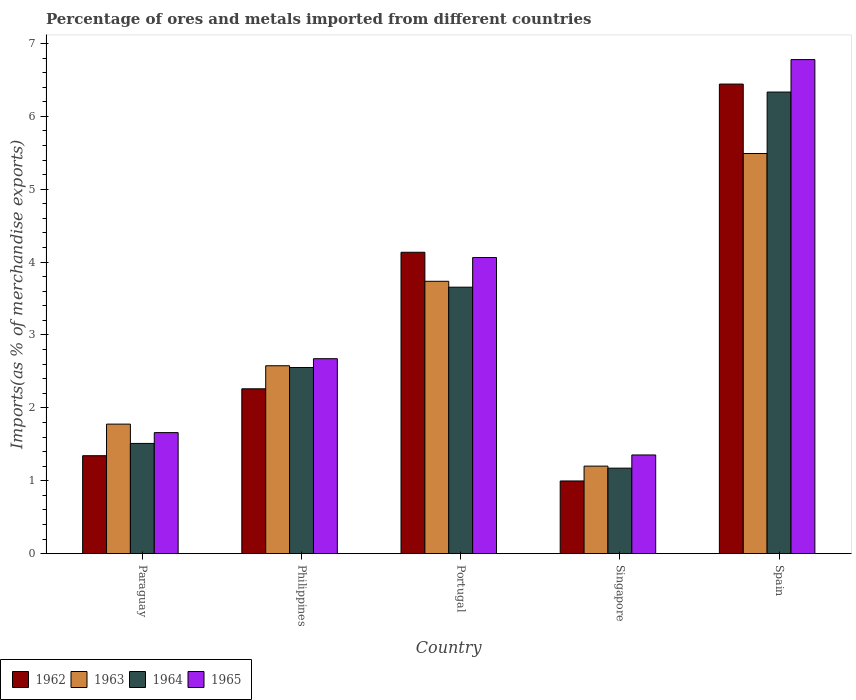Are the number of bars per tick equal to the number of legend labels?
Offer a terse response. Yes. Are the number of bars on each tick of the X-axis equal?
Offer a very short reply. Yes. How many bars are there on the 5th tick from the left?
Offer a terse response. 4. What is the percentage of imports to different countries in 1965 in Singapore?
Your answer should be compact. 1.35. Across all countries, what is the maximum percentage of imports to different countries in 1965?
Your answer should be very brief. 6.78. Across all countries, what is the minimum percentage of imports to different countries in 1963?
Keep it short and to the point. 1.2. In which country was the percentage of imports to different countries in 1963 maximum?
Offer a terse response. Spain. In which country was the percentage of imports to different countries in 1965 minimum?
Give a very brief answer. Singapore. What is the total percentage of imports to different countries in 1963 in the graph?
Your answer should be compact. 14.78. What is the difference between the percentage of imports to different countries in 1962 in Portugal and that in Singapore?
Your response must be concise. 3.14. What is the difference between the percentage of imports to different countries in 1962 in Singapore and the percentage of imports to different countries in 1964 in Philippines?
Offer a very short reply. -1.56. What is the average percentage of imports to different countries in 1962 per country?
Offer a terse response. 3.04. What is the difference between the percentage of imports to different countries of/in 1964 and percentage of imports to different countries of/in 1962 in Portugal?
Make the answer very short. -0.48. In how many countries, is the percentage of imports to different countries in 1962 greater than 6.8 %?
Keep it short and to the point. 0. What is the ratio of the percentage of imports to different countries in 1962 in Singapore to that in Spain?
Provide a succinct answer. 0.15. Is the percentage of imports to different countries in 1963 in Portugal less than that in Spain?
Your answer should be compact. Yes. What is the difference between the highest and the second highest percentage of imports to different countries in 1964?
Your answer should be very brief. -1.1. What is the difference between the highest and the lowest percentage of imports to different countries in 1963?
Your response must be concise. 4.29. Is it the case that in every country, the sum of the percentage of imports to different countries in 1962 and percentage of imports to different countries in 1965 is greater than the sum of percentage of imports to different countries in 1963 and percentage of imports to different countries in 1964?
Provide a succinct answer. No. What does the 4th bar from the left in Portugal represents?
Ensure brevity in your answer.  1965. What does the 2nd bar from the right in Paraguay represents?
Provide a short and direct response. 1964. How many bars are there?
Offer a very short reply. 20. How many countries are there in the graph?
Ensure brevity in your answer.  5. What is the difference between two consecutive major ticks on the Y-axis?
Provide a short and direct response. 1. Does the graph contain any zero values?
Your answer should be very brief. No. How are the legend labels stacked?
Offer a terse response. Horizontal. What is the title of the graph?
Give a very brief answer. Percentage of ores and metals imported from different countries. Does "1997" appear as one of the legend labels in the graph?
Offer a very short reply. No. What is the label or title of the X-axis?
Offer a very short reply. Country. What is the label or title of the Y-axis?
Your answer should be compact. Imports(as % of merchandise exports). What is the Imports(as % of merchandise exports) of 1962 in Paraguay?
Ensure brevity in your answer.  1.34. What is the Imports(as % of merchandise exports) in 1963 in Paraguay?
Your answer should be very brief. 1.78. What is the Imports(as % of merchandise exports) in 1964 in Paraguay?
Ensure brevity in your answer.  1.51. What is the Imports(as % of merchandise exports) of 1965 in Paraguay?
Provide a short and direct response. 1.66. What is the Imports(as % of merchandise exports) in 1962 in Philippines?
Make the answer very short. 2.26. What is the Imports(as % of merchandise exports) in 1963 in Philippines?
Provide a succinct answer. 2.58. What is the Imports(as % of merchandise exports) of 1964 in Philippines?
Make the answer very short. 2.55. What is the Imports(as % of merchandise exports) in 1965 in Philippines?
Provide a succinct answer. 2.67. What is the Imports(as % of merchandise exports) of 1962 in Portugal?
Give a very brief answer. 4.13. What is the Imports(as % of merchandise exports) of 1963 in Portugal?
Your answer should be very brief. 3.74. What is the Imports(as % of merchandise exports) of 1964 in Portugal?
Ensure brevity in your answer.  3.66. What is the Imports(as % of merchandise exports) of 1965 in Portugal?
Your answer should be compact. 4.06. What is the Imports(as % of merchandise exports) of 1962 in Singapore?
Offer a very short reply. 1. What is the Imports(as % of merchandise exports) in 1963 in Singapore?
Give a very brief answer. 1.2. What is the Imports(as % of merchandise exports) of 1964 in Singapore?
Your answer should be compact. 1.17. What is the Imports(as % of merchandise exports) of 1965 in Singapore?
Make the answer very short. 1.35. What is the Imports(as % of merchandise exports) in 1962 in Spain?
Make the answer very short. 6.44. What is the Imports(as % of merchandise exports) of 1963 in Spain?
Your response must be concise. 5.49. What is the Imports(as % of merchandise exports) of 1964 in Spain?
Make the answer very short. 6.33. What is the Imports(as % of merchandise exports) of 1965 in Spain?
Ensure brevity in your answer.  6.78. Across all countries, what is the maximum Imports(as % of merchandise exports) in 1962?
Your response must be concise. 6.44. Across all countries, what is the maximum Imports(as % of merchandise exports) in 1963?
Keep it short and to the point. 5.49. Across all countries, what is the maximum Imports(as % of merchandise exports) of 1964?
Make the answer very short. 6.33. Across all countries, what is the maximum Imports(as % of merchandise exports) in 1965?
Offer a very short reply. 6.78. Across all countries, what is the minimum Imports(as % of merchandise exports) of 1962?
Ensure brevity in your answer.  1. Across all countries, what is the minimum Imports(as % of merchandise exports) in 1963?
Your answer should be compact. 1.2. Across all countries, what is the minimum Imports(as % of merchandise exports) of 1964?
Provide a succinct answer. 1.17. Across all countries, what is the minimum Imports(as % of merchandise exports) of 1965?
Make the answer very short. 1.35. What is the total Imports(as % of merchandise exports) in 1962 in the graph?
Offer a terse response. 15.18. What is the total Imports(as % of merchandise exports) of 1963 in the graph?
Offer a terse response. 14.78. What is the total Imports(as % of merchandise exports) in 1964 in the graph?
Provide a succinct answer. 15.23. What is the total Imports(as % of merchandise exports) of 1965 in the graph?
Ensure brevity in your answer.  16.53. What is the difference between the Imports(as % of merchandise exports) in 1962 in Paraguay and that in Philippines?
Provide a short and direct response. -0.92. What is the difference between the Imports(as % of merchandise exports) of 1963 in Paraguay and that in Philippines?
Your answer should be compact. -0.8. What is the difference between the Imports(as % of merchandise exports) in 1964 in Paraguay and that in Philippines?
Your response must be concise. -1.04. What is the difference between the Imports(as % of merchandise exports) in 1965 in Paraguay and that in Philippines?
Offer a terse response. -1.01. What is the difference between the Imports(as % of merchandise exports) of 1962 in Paraguay and that in Portugal?
Offer a terse response. -2.79. What is the difference between the Imports(as % of merchandise exports) in 1963 in Paraguay and that in Portugal?
Keep it short and to the point. -1.96. What is the difference between the Imports(as % of merchandise exports) of 1964 in Paraguay and that in Portugal?
Offer a very short reply. -2.14. What is the difference between the Imports(as % of merchandise exports) of 1965 in Paraguay and that in Portugal?
Your answer should be compact. -2.4. What is the difference between the Imports(as % of merchandise exports) of 1962 in Paraguay and that in Singapore?
Offer a very short reply. 0.35. What is the difference between the Imports(as % of merchandise exports) of 1963 in Paraguay and that in Singapore?
Provide a succinct answer. 0.58. What is the difference between the Imports(as % of merchandise exports) in 1964 in Paraguay and that in Singapore?
Keep it short and to the point. 0.34. What is the difference between the Imports(as % of merchandise exports) of 1965 in Paraguay and that in Singapore?
Give a very brief answer. 0.31. What is the difference between the Imports(as % of merchandise exports) of 1962 in Paraguay and that in Spain?
Keep it short and to the point. -5.1. What is the difference between the Imports(as % of merchandise exports) of 1963 in Paraguay and that in Spain?
Provide a succinct answer. -3.71. What is the difference between the Imports(as % of merchandise exports) in 1964 in Paraguay and that in Spain?
Provide a succinct answer. -4.82. What is the difference between the Imports(as % of merchandise exports) in 1965 in Paraguay and that in Spain?
Ensure brevity in your answer.  -5.12. What is the difference between the Imports(as % of merchandise exports) in 1962 in Philippines and that in Portugal?
Provide a short and direct response. -1.87. What is the difference between the Imports(as % of merchandise exports) in 1963 in Philippines and that in Portugal?
Make the answer very short. -1.16. What is the difference between the Imports(as % of merchandise exports) in 1964 in Philippines and that in Portugal?
Offer a very short reply. -1.1. What is the difference between the Imports(as % of merchandise exports) in 1965 in Philippines and that in Portugal?
Offer a terse response. -1.39. What is the difference between the Imports(as % of merchandise exports) in 1962 in Philippines and that in Singapore?
Provide a short and direct response. 1.26. What is the difference between the Imports(as % of merchandise exports) in 1963 in Philippines and that in Singapore?
Provide a short and direct response. 1.38. What is the difference between the Imports(as % of merchandise exports) of 1964 in Philippines and that in Singapore?
Your answer should be very brief. 1.38. What is the difference between the Imports(as % of merchandise exports) of 1965 in Philippines and that in Singapore?
Offer a very short reply. 1.32. What is the difference between the Imports(as % of merchandise exports) of 1962 in Philippines and that in Spain?
Your answer should be compact. -4.18. What is the difference between the Imports(as % of merchandise exports) in 1963 in Philippines and that in Spain?
Ensure brevity in your answer.  -2.91. What is the difference between the Imports(as % of merchandise exports) in 1964 in Philippines and that in Spain?
Offer a terse response. -3.78. What is the difference between the Imports(as % of merchandise exports) in 1965 in Philippines and that in Spain?
Your answer should be very brief. -4.1. What is the difference between the Imports(as % of merchandise exports) in 1962 in Portugal and that in Singapore?
Provide a short and direct response. 3.14. What is the difference between the Imports(as % of merchandise exports) in 1963 in Portugal and that in Singapore?
Give a very brief answer. 2.54. What is the difference between the Imports(as % of merchandise exports) in 1964 in Portugal and that in Singapore?
Keep it short and to the point. 2.48. What is the difference between the Imports(as % of merchandise exports) in 1965 in Portugal and that in Singapore?
Offer a very short reply. 2.71. What is the difference between the Imports(as % of merchandise exports) of 1962 in Portugal and that in Spain?
Your answer should be compact. -2.31. What is the difference between the Imports(as % of merchandise exports) of 1963 in Portugal and that in Spain?
Offer a very short reply. -1.75. What is the difference between the Imports(as % of merchandise exports) of 1964 in Portugal and that in Spain?
Provide a succinct answer. -2.68. What is the difference between the Imports(as % of merchandise exports) of 1965 in Portugal and that in Spain?
Ensure brevity in your answer.  -2.72. What is the difference between the Imports(as % of merchandise exports) in 1962 in Singapore and that in Spain?
Your response must be concise. -5.45. What is the difference between the Imports(as % of merchandise exports) of 1963 in Singapore and that in Spain?
Give a very brief answer. -4.29. What is the difference between the Imports(as % of merchandise exports) of 1964 in Singapore and that in Spain?
Keep it short and to the point. -5.16. What is the difference between the Imports(as % of merchandise exports) in 1965 in Singapore and that in Spain?
Your answer should be compact. -5.42. What is the difference between the Imports(as % of merchandise exports) of 1962 in Paraguay and the Imports(as % of merchandise exports) of 1963 in Philippines?
Ensure brevity in your answer.  -1.23. What is the difference between the Imports(as % of merchandise exports) of 1962 in Paraguay and the Imports(as % of merchandise exports) of 1964 in Philippines?
Ensure brevity in your answer.  -1.21. What is the difference between the Imports(as % of merchandise exports) in 1962 in Paraguay and the Imports(as % of merchandise exports) in 1965 in Philippines?
Provide a succinct answer. -1.33. What is the difference between the Imports(as % of merchandise exports) of 1963 in Paraguay and the Imports(as % of merchandise exports) of 1964 in Philippines?
Offer a terse response. -0.78. What is the difference between the Imports(as % of merchandise exports) in 1963 in Paraguay and the Imports(as % of merchandise exports) in 1965 in Philippines?
Provide a succinct answer. -0.9. What is the difference between the Imports(as % of merchandise exports) in 1964 in Paraguay and the Imports(as % of merchandise exports) in 1965 in Philippines?
Your answer should be very brief. -1.16. What is the difference between the Imports(as % of merchandise exports) in 1962 in Paraguay and the Imports(as % of merchandise exports) in 1963 in Portugal?
Your answer should be very brief. -2.39. What is the difference between the Imports(as % of merchandise exports) in 1962 in Paraguay and the Imports(as % of merchandise exports) in 1964 in Portugal?
Give a very brief answer. -2.31. What is the difference between the Imports(as % of merchandise exports) in 1962 in Paraguay and the Imports(as % of merchandise exports) in 1965 in Portugal?
Your response must be concise. -2.72. What is the difference between the Imports(as % of merchandise exports) in 1963 in Paraguay and the Imports(as % of merchandise exports) in 1964 in Portugal?
Provide a short and direct response. -1.88. What is the difference between the Imports(as % of merchandise exports) of 1963 in Paraguay and the Imports(as % of merchandise exports) of 1965 in Portugal?
Keep it short and to the point. -2.29. What is the difference between the Imports(as % of merchandise exports) in 1964 in Paraguay and the Imports(as % of merchandise exports) in 1965 in Portugal?
Provide a succinct answer. -2.55. What is the difference between the Imports(as % of merchandise exports) in 1962 in Paraguay and the Imports(as % of merchandise exports) in 1963 in Singapore?
Your answer should be compact. 0.14. What is the difference between the Imports(as % of merchandise exports) of 1962 in Paraguay and the Imports(as % of merchandise exports) of 1964 in Singapore?
Offer a terse response. 0.17. What is the difference between the Imports(as % of merchandise exports) of 1962 in Paraguay and the Imports(as % of merchandise exports) of 1965 in Singapore?
Your response must be concise. -0.01. What is the difference between the Imports(as % of merchandise exports) of 1963 in Paraguay and the Imports(as % of merchandise exports) of 1964 in Singapore?
Provide a succinct answer. 0.6. What is the difference between the Imports(as % of merchandise exports) in 1963 in Paraguay and the Imports(as % of merchandise exports) in 1965 in Singapore?
Provide a succinct answer. 0.42. What is the difference between the Imports(as % of merchandise exports) in 1964 in Paraguay and the Imports(as % of merchandise exports) in 1965 in Singapore?
Your response must be concise. 0.16. What is the difference between the Imports(as % of merchandise exports) in 1962 in Paraguay and the Imports(as % of merchandise exports) in 1963 in Spain?
Keep it short and to the point. -4.15. What is the difference between the Imports(as % of merchandise exports) in 1962 in Paraguay and the Imports(as % of merchandise exports) in 1964 in Spain?
Offer a terse response. -4.99. What is the difference between the Imports(as % of merchandise exports) in 1962 in Paraguay and the Imports(as % of merchandise exports) in 1965 in Spain?
Offer a very short reply. -5.43. What is the difference between the Imports(as % of merchandise exports) of 1963 in Paraguay and the Imports(as % of merchandise exports) of 1964 in Spain?
Your answer should be very brief. -4.56. What is the difference between the Imports(as % of merchandise exports) of 1963 in Paraguay and the Imports(as % of merchandise exports) of 1965 in Spain?
Offer a terse response. -5. What is the difference between the Imports(as % of merchandise exports) in 1964 in Paraguay and the Imports(as % of merchandise exports) in 1965 in Spain?
Your answer should be compact. -5.27. What is the difference between the Imports(as % of merchandise exports) in 1962 in Philippines and the Imports(as % of merchandise exports) in 1963 in Portugal?
Ensure brevity in your answer.  -1.47. What is the difference between the Imports(as % of merchandise exports) of 1962 in Philippines and the Imports(as % of merchandise exports) of 1964 in Portugal?
Offer a terse response. -1.39. What is the difference between the Imports(as % of merchandise exports) in 1962 in Philippines and the Imports(as % of merchandise exports) in 1965 in Portugal?
Your answer should be very brief. -1.8. What is the difference between the Imports(as % of merchandise exports) in 1963 in Philippines and the Imports(as % of merchandise exports) in 1964 in Portugal?
Keep it short and to the point. -1.08. What is the difference between the Imports(as % of merchandise exports) of 1963 in Philippines and the Imports(as % of merchandise exports) of 1965 in Portugal?
Keep it short and to the point. -1.48. What is the difference between the Imports(as % of merchandise exports) of 1964 in Philippines and the Imports(as % of merchandise exports) of 1965 in Portugal?
Your answer should be compact. -1.51. What is the difference between the Imports(as % of merchandise exports) in 1962 in Philippines and the Imports(as % of merchandise exports) in 1963 in Singapore?
Make the answer very short. 1.06. What is the difference between the Imports(as % of merchandise exports) in 1962 in Philippines and the Imports(as % of merchandise exports) in 1964 in Singapore?
Your response must be concise. 1.09. What is the difference between the Imports(as % of merchandise exports) of 1962 in Philippines and the Imports(as % of merchandise exports) of 1965 in Singapore?
Provide a succinct answer. 0.91. What is the difference between the Imports(as % of merchandise exports) of 1963 in Philippines and the Imports(as % of merchandise exports) of 1964 in Singapore?
Offer a very short reply. 1.4. What is the difference between the Imports(as % of merchandise exports) in 1963 in Philippines and the Imports(as % of merchandise exports) in 1965 in Singapore?
Offer a terse response. 1.22. What is the difference between the Imports(as % of merchandise exports) in 1964 in Philippines and the Imports(as % of merchandise exports) in 1965 in Singapore?
Make the answer very short. 1.2. What is the difference between the Imports(as % of merchandise exports) in 1962 in Philippines and the Imports(as % of merchandise exports) in 1963 in Spain?
Provide a short and direct response. -3.23. What is the difference between the Imports(as % of merchandise exports) of 1962 in Philippines and the Imports(as % of merchandise exports) of 1964 in Spain?
Provide a short and direct response. -4.07. What is the difference between the Imports(as % of merchandise exports) of 1962 in Philippines and the Imports(as % of merchandise exports) of 1965 in Spain?
Offer a very short reply. -4.52. What is the difference between the Imports(as % of merchandise exports) in 1963 in Philippines and the Imports(as % of merchandise exports) in 1964 in Spain?
Your answer should be compact. -3.75. What is the difference between the Imports(as % of merchandise exports) of 1963 in Philippines and the Imports(as % of merchandise exports) of 1965 in Spain?
Give a very brief answer. -4.2. What is the difference between the Imports(as % of merchandise exports) in 1964 in Philippines and the Imports(as % of merchandise exports) in 1965 in Spain?
Offer a very short reply. -4.22. What is the difference between the Imports(as % of merchandise exports) in 1962 in Portugal and the Imports(as % of merchandise exports) in 1963 in Singapore?
Ensure brevity in your answer.  2.93. What is the difference between the Imports(as % of merchandise exports) of 1962 in Portugal and the Imports(as % of merchandise exports) of 1964 in Singapore?
Your answer should be very brief. 2.96. What is the difference between the Imports(as % of merchandise exports) of 1962 in Portugal and the Imports(as % of merchandise exports) of 1965 in Singapore?
Keep it short and to the point. 2.78. What is the difference between the Imports(as % of merchandise exports) of 1963 in Portugal and the Imports(as % of merchandise exports) of 1964 in Singapore?
Provide a short and direct response. 2.56. What is the difference between the Imports(as % of merchandise exports) of 1963 in Portugal and the Imports(as % of merchandise exports) of 1965 in Singapore?
Your answer should be compact. 2.38. What is the difference between the Imports(as % of merchandise exports) of 1964 in Portugal and the Imports(as % of merchandise exports) of 1965 in Singapore?
Your response must be concise. 2.3. What is the difference between the Imports(as % of merchandise exports) of 1962 in Portugal and the Imports(as % of merchandise exports) of 1963 in Spain?
Make the answer very short. -1.36. What is the difference between the Imports(as % of merchandise exports) in 1962 in Portugal and the Imports(as % of merchandise exports) in 1964 in Spain?
Give a very brief answer. -2.2. What is the difference between the Imports(as % of merchandise exports) in 1962 in Portugal and the Imports(as % of merchandise exports) in 1965 in Spain?
Your answer should be very brief. -2.64. What is the difference between the Imports(as % of merchandise exports) of 1963 in Portugal and the Imports(as % of merchandise exports) of 1964 in Spain?
Your answer should be very brief. -2.6. What is the difference between the Imports(as % of merchandise exports) of 1963 in Portugal and the Imports(as % of merchandise exports) of 1965 in Spain?
Your answer should be compact. -3.04. What is the difference between the Imports(as % of merchandise exports) of 1964 in Portugal and the Imports(as % of merchandise exports) of 1965 in Spain?
Provide a short and direct response. -3.12. What is the difference between the Imports(as % of merchandise exports) of 1962 in Singapore and the Imports(as % of merchandise exports) of 1963 in Spain?
Your answer should be very brief. -4.49. What is the difference between the Imports(as % of merchandise exports) of 1962 in Singapore and the Imports(as % of merchandise exports) of 1964 in Spain?
Offer a very short reply. -5.34. What is the difference between the Imports(as % of merchandise exports) in 1962 in Singapore and the Imports(as % of merchandise exports) in 1965 in Spain?
Give a very brief answer. -5.78. What is the difference between the Imports(as % of merchandise exports) of 1963 in Singapore and the Imports(as % of merchandise exports) of 1964 in Spain?
Provide a short and direct response. -5.13. What is the difference between the Imports(as % of merchandise exports) in 1963 in Singapore and the Imports(as % of merchandise exports) in 1965 in Spain?
Offer a very short reply. -5.58. What is the difference between the Imports(as % of merchandise exports) in 1964 in Singapore and the Imports(as % of merchandise exports) in 1965 in Spain?
Your answer should be compact. -5.61. What is the average Imports(as % of merchandise exports) of 1962 per country?
Provide a succinct answer. 3.04. What is the average Imports(as % of merchandise exports) of 1963 per country?
Your answer should be very brief. 2.96. What is the average Imports(as % of merchandise exports) in 1964 per country?
Your answer should be very brief. 3.05. What is the average Imports(as % of merchandise exports) in 1965 per country?
Your answer should be very brief. 3.31. What is the difference between the Imports(as % of merchandise exports) of 1962 and Imports(as % of merchandise exports) of 1963 in Paraguay?
Provide a short and direct response. -0.43. What is the difference between the Imports(as % of merchandise exports) in 1962 and Imports(as % of merchandise exports) in 1964 in Paraguay?
Ensure brevity in your answer.  -0.17. What is the difference between the Imports(as % of merchandise exports) in 1962 and Imports(as % of merchandise exports) in 1965 in Paraguay?
Your answer should be very brief. -0.32. What is the difference between the Imports(as % of merchandise exports) of 1963 and Imports(as % of merchandise exports) of 1964 in Paraguay?
Make the answer very short. 0.26. What is the difference between the Imports(as % of merchandise exports) of 1963 and Imports(as % of merchandise exports) of 1965 in Paraguay?
Keep it short and to the point. 0.12. What is the difference between the Imports(as % of merchandise exports) of 1964 and Imports(as % of merchandise exports) of 1965 in Paraguay?
Provide a short and direct response. -0.15. What is the difference between the Imports(as % of merchandise exports) of 1962 and Imports(as % of merchandise exports) of 1963 in Philippines?
Ensure brevity in your answer.  -0.32. What is the difference between the Imports(as % of merchandise exports) of 1962 and Imports(as % of merchandise exports) of 1964 in Philippines?
Offer a terse response. -0.29. What is the difference between the Imports(as % of merchandise exports) of 1962 and Imports(as % of merchandise exports) of 1965 in Philippines?
Your response must be concise. -0.41. What is the difference between the Imports(as % of merchandise exports) of 1963 and Imports(as % of merchandise exports) of 1964 in Philippines?
Offer a terse response. 0.02. What is the difference between the Imports(as % of merchandise exports) of 1963 and Imports(as % of merchandise exports) of 1965 in Philippines?
Your answer should be compact. -0.1. What is the difference between the Imports(as % of merchandise exports) of 1964 and Imports(as % of merchandise exports) of 1965 in Philippines?
Keep it short and to the point. -0.12. What is the difference between the Imports(as % of merchandise exports) of 1962 and Imports(as % of merchandise exports) of 1963 in Portugal?
Offer a very short reply. 0.4. What is the difference between the Imports(as % of merchandise exports) in 1962 and Imports(as % of merchandise exports) in 1964 in Portugal?
Provide a short and direct response. 0.48. What is the difference between the Imports(as % of merchandise exports) in 1962 and Imports(as % of merchandise exports) in 1965 in Portugal?
Your response must be concise. 0.07. What is the difference between the Imports(as % of merchandise exports) in 1963 and Imports(as % of merchandise exports) in 1964 in Portugal?
Your answer should be very brief. 0.08. What is the difference between the Imports(as % of merchandise exports) of 1963 and Imports(as % of merchandise exports) of 1965 in Portugal?
Provide a succinct answer. -0.33. What is the difference between the Imports(as % of merchandise exports) in 1964 and Imports(as % of merchandise exports) in 1965 in Portugal?
Make the answer very short. -0.41. What is the difference between the Imports(as % of merchandise exports) of 1962 and Imports(as % of merchandise exports) of 1963 in Singapore?
Provide a succinct answer. -0.2. What is the difference between the Imports(as % of merchandise exports) of 1962 and Imports(as % of merchandise exports) of 1964 in Singapore?
Offer a very short reply. -0.18. What is the difference between the Imports(as % of merchandise exports) in 1962 and Imports(as % of merchandise exports) in 1965 in Singapore?
Make the answer very short. -0.36. What is the difference between the Imports(as % of merchandise exports) in 1963 and Imports(as % of merchandise exports) in 1964 in Singapore?
Your answer should be compact. 0.03. What is the difference between the Imports(as % of merchandise exports) in 1963 and Imports(as % of merchandise exports) in 1965 in Singapore?
Your response must be concise. -0.15. What is the difference between the Imports(as % of merchandise exports) of 1964 and Imports(as % of merchandise exports) of 1965 in Singapore?
Offer a terse response. -0.18. What is the difference between the Imports(as % of merchandise exports) of 1962 and Imports(as % of merchandise exports) of 1964 in Spain?
Ensure brevity in your answer.  0.11. What is the difference between the Imports(as % of merchandise exports) in 1962 and Imports(as % of merchandise exports) in 1965 in Spain?
Provide a short and direct response. -0.34. What is the difference between the Imports(as % of merchandise exports) of 1963 and Imports(as % of merchandise exports) of 1964 in Spain?
Ensure brevity in your answer.  -0.84. What is the difference between the Imports(as % of merchandise exports) of 1963 and Imports(as % of merchandise exports) of 1965 in Spain?
Offer a very short reply. -1.29. What is the difference between the Imports(as % of merchandise exports) of 1964 and Imports(as % of merchandise exports) of 1965 in Spain?
Make the answer very short. -0.45. What is the ratio of the Imports(as % of merchandise exports) of 1962 in Paraguay to that in Philippines?
Your answer should be very brief. 0.59. What is the ratio of the Imports(as % of merchandise exports) in 1963 in Paraguay to that in Philippines?
Offer a terse response. 0.69. What is the ratio of the Imports(as % of merchandise exports) in 1964 in Paraguay to that in Philippines?
Your answer should be very brief. 0.59. What is the ratio of the Imports(as % of merchandise exports) in 1965 in Paraguay to that in Philippines?
Keep it short and to the point. 0.62. What is the ratio of the Imports(as % of merchandise exports) of 1962 in Paraguay to that in Portugal?
Your answer should be compact. 0.33. What is the ratio of the Imports(as % of merchandise exports) in 1963 in Paraguay to that in Portugal?
Offer a terse response. 0.48. What is the ratio of the Imports(as % of merchandise exports) of 1964 in Paraguay to that in Portugal?
Provide a short and direct response. 0.41. What is the ratio of the Imports(as % of merchandise exports) in 1965 in Paraguay to that in Portugal?
Provide a succinct answer. 0.41. What is the ratio of the Imports(as % of merchandise exports) of 1962 in Paraguay to that in Singapore?
Your response must be concise. 1.35. What is the ratio of the Imports(as % of merchandise exports) of 1963 in Paraguay to that in Singapore?
Your answer should be compact. 1.48. What is the ratio of the Imports(as % of merchandise exports) in 1964 in Paraguay to that in Singapore?
Give a very brief answer. 1.29. What is the ratio of the Imports(as % of merchandise exports) of 1965 in Paraguay to that in Singapore?
Keep it short and to the point. 1.23. What is the ratio of the Imports(as % of merchandise exports) in 1962 in Paraguay to that in Spain?
Ensure brevity in your answer.  0.21. What is the ratio of the Imports(as % of merchandise exports) in 1963 in Paraguay to that in Spain?
Your response must be concise. 0.32. What is the ratio of the Imports(as % of merchandise exports) in 1964 in Paraguay to that in Spain?
Your answer should be very brief. 0.24. What is the ratio of the Imports(as % of merchandise exports) in 1965 in Paraguay to that in Spain?
Offer a terse response. 0.24. What is the ratio of the Imports(as % of merchandise exports) in 1962 in Philippines to that in Portugal?
Offer a very short reply. 0.55. What is the ratio of the Imports(as % of merchandise exports) of 1963 in Philippines to that in Portugal?
Your answer should be very brief. 0.69. What is the ratio of the Imports(as % of merchandise exports) of 1964 in Philippines to that in Portugal?
Make the answer very short. 0.7. What is the ratio of the Imports(as % of merchandise exports) of 1965 in Philippines to that in Portugal?
Give a very brief answer. 0.66. What is the ratio of the Imports(as % of merchandise exports) of 1962 in Philippines to that in Singapore?
Ensure brevity in your answer.  2.27. What is the ratio of the Imports(as % of merchandise exports) in 1963 in Philippines to that in Singapore?
Your answer should be very brief. 2.15. What is the ratio of the Imports(as % of merchandise exports) of 1964 in Philippines to that in Singapore?
Your response must be concise. 2.18. What is the ratio of the Imports(as % of merchandise exports) of 1965 in Philippines to that in Singapore?
Give a very brief answer. 1.98. What is the ratio of the Imports(as % of merchandise exports) of 1962 in Philippines to that in Spain?
Keep it short and to the point. 0.35. What is the ratio of the Imports(as % of merchandise exports) of 1963 in Philippines to that in Spain?
Ensure brevity in your answer.  0.47. What is the ratio of the Imports(as % of merchandise exports) of 1964 in Philippines to that in Spain?
Provide a short and direct response. 0.4. What is the ratio of the Imports(as % of merchandise exports) in 1965 in Philippines to that in Spain?
Keep it short and to the point. 0.39. What is the ratio of the Imports(as % of merchandise exports) of 1962 in Portugal to that in Singapore?
Provide a succinct answer. 4.15. What is the ratio of the Imports(as % of merchandise exports) of 1963 in Portugal to that in Singapore?
Give a very brief answer. 3.11. What is the ratio of the Imports(as % of merchandise exports) in 1964 in Portugal to that in Singapore?
Ensure brevity in your answer.  3.12. What is the ratio of the Imports(as % of merchandise exports) in 1965 in Portugal to that in Singapore?
Provide a succinct answer. 3. What is the ratio of the Imports(as % of merchandise exports) in 1962 in Portugal to that in Spain?
Ensure brevity in your answer.  0.64. What is the ratio of the Imports(as % of merchandise exports) of 1963 in Portugal to that in Spain?
Make the answer very short. 0.68. What is the ratio of the Imports(as % of merchandise exports) in 1964 in Portugal to that in Spain?
Offer a very short reply. 0.58. What is the ratio of the Imports(as % of merchandise exports) of 1965 in Portugal to that in Spain?
Offer a very short reply. 0.6. What is the ratio of the Imports(as % of merchandise exports) in 1962 in Singapore to that in Spain?
Your response must be concise. 0.15. What is the ratio of the Imports(as % of merchandise exports) of 1963 in Singapore to that in Spain?
Offer a very short reply. 0.22. What is the ratio of the Imports(as % of merchandise exports) in 1964 in Singapore to that in Spain?
Keep it short and to the point. 0.19. What is the ratio of the Imports(as % of merchandise exports) of 1965 in Singapore to that in Spain?
Offer a very short reply. 0.2. What is the difference between the highest and the second highest Imports(as % of merchandise exports) of 1962?
Your answer should be compact. 2.31. What is the difference between the highest and the second highest Imports(as % of merchandise exports) in 1963?
Offer a terse response. 1.75. What is the difference between the highest and the second highest Imports(as % of merchandise exports) in 1964?
Provide a succinct answer. 2.68. What is the difference between the highest and the second highest Imports(as % of merchandise exports) in 1965?
Keep it short and to the point. 2.72. What is the difference between the highest and the lowest Imports(as % of merchandise exports) of 1962?
Your answer should be compact. 5.45. What is the difference between the highest and the lowest Imports(as % of merchandise exports) of 1963?
Make the answer very short. 4.29. What is the difference between the highest and the lowest Imports(as % of merchandise exports) in 1964?
Your response must be concise. 5.16. What is the difference between the highest and the lowest Imports(as % of merchandise exports) in 1965?
Keep it short and to the point. 5.42. 